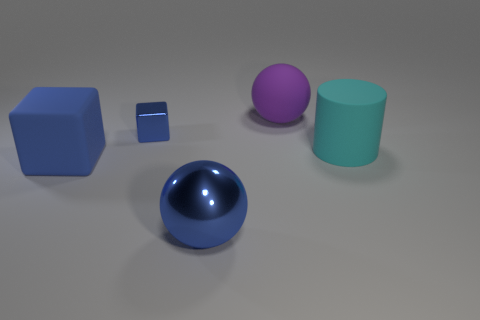Are there any other things that have the same size as the blue shiny block?
Ensure brevity in your answer.  No. Are there any big green rubber things?
Your answer should be very brief. No. What number of brown metal things are the same size as the purple rubber thing?
Provide a short and direct response. 0. What number of blue objects are in front of the tiny blue shiny object and on the left side of the large shiny ball?
Your answer should be compact. 1. There is a shiny object in front of the cyan cylinder; is its size the same as the cyan thing?
Ensure brevity in your answer.  Yes. Are there any rubber objects of the same color as the matte sphere?
Give a very brief answer. No. What is the size of the cylinder that is made of the same material as the purple object?
Offer a terse response. Large. Are there more large rubber cylinders to the left of the big cylinder than large cyan cylinders left of the blue rubber block?
Ensure brevity in your answer.  No. What number of other things are there of the same material as the cylinder
Provide a short and direct response. 2. Is the material of the block in front of the small metallic object the same as the small cube?
Make the answer very short. No. 